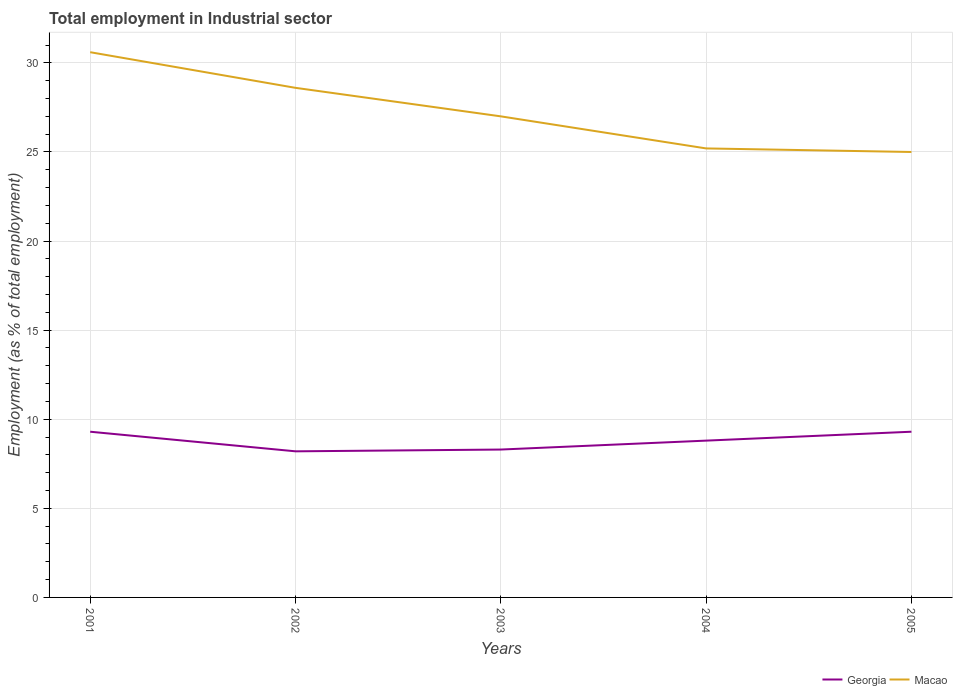How many different coloured lines are there?
Your answer should be compact. 2. What is the total employment in industrial sector in Macao in the graph?
Provide a succinct answer. 0.2. What is the difference between the highest and the second highest employment in industrial sector in Georgia?
Keep it short and to the point. 1.1. What is the difference between the highest and the lowest employment in industrial sector in Georgia?
Provide a succinct answer. 3. Is the employment in industrial sector in Macao strictly greater than the employment in industrial sector in Georgia over the years?
Provide a short and direct response. No. How many years are there in the graph?
Your answer should be very brief. 5. Does the graph contain any zero values?
Provide a succinct answer. No. What is the title of the graph?
Your answer should be compact. Total employment in Industrial sector. What is the label or title of the X-axis?
Offer a terse response. Years. What is the label or title of the Y-axis?
Offer a very short reply. Employment (as % of total employment). What is the Employment (as % of total employment) in Georgia in 2001?
Your answer should be compact. 9.3. What is the Employment (as % of total employment) of Macao in 2001?
Offer a very short reply. 30.6. What is the Employment (as % of total employment) in Georgia in 2002?
Offer a terse response. 8.2. What is the Employment (as % of total employment) in Macao in 2002?
Your response must be concise. 28.6. What is the Employment (as % of total employment) in Georgia in 2003?
Offer a terse response. 8.3. What is the Employment (as % of total employment) of Georgia in 2004?
Offer a terse response. 8.8. What is the Employment (as % of total employment) in Macao in 2004?
Ensure brevity in your answer.  25.2. What is the Employment (as % of total employment) in Georgia in 2005?
Provide a short and direct response. 9.3. Across all years, what is the maximum Employment (as % of total employment) in Georgia?
Give a very brief answer. 9.3. Across all years, what is the maximum Employment (as % of total employment) in Macao?
Give a very brief answer. 30.6. Across all years, what is the minimum Employment (as % of total employment) of Georgia?
Your response must be concise. 8.2. What is the total Employment (as % of total employment) in Georgia in the graph?
Make the answer very short. 43.9. What is the total Employment (as % of total employment) of Macao in the graph?
Your response must be concise. 136.4. What is the difference between the Employment (as % of total employment) of Macao in 2001 and that in 2003?
Provide a short and direct response. 3.6. What is the difference between the Employment (as % of total employment) of Georgia in 2001 and that in 2005?
Your response must be concise. 0. What is the difference between the Employment (as % of total employment) of Georgia in 2002 and that in 2003?
Provide a succinct answer. -0.1. What is the difference between the Employment (as % of total employment) of Macao in 2002 and that in 2003?
Offer a terse response. 1.6. What is the difference between the Employment (as % of total employment) in Georgia in 2002 and that in 2005?
Make the answer very short. -1.1. What is the difference between the Employment (as % of total employment) of Macao in 2002 and that in 2005?
Offer a terse response. 3.6. What is the difference between the Employment (as % of total employment) of Georgia in 2003 and that in 2004?
Your response must be concise. -0.5. What is the difference between the Employment (as % of total employment) of Macao in 2003 and that in 2004?
Keep it short and to the point. 1.8. What is the difference between the Employment (as % of total employment) in Georgia in 2003 and that in 2005?
Your response must be concise. -1. What is the difference between the Employment (as % of total employment) in Macao in 2003 and that in 2005?
Your answer should be compact. 2. What is the difference between the Employment (as % of total employment) of Georgia in 2004 and that in 2005?
Your answer should be very brief. -0.5. What is the difference between the Employment (as % of total employment) in Georgia in 2001 and the Employment (as % of total employment) in Macao in 2002?
Give a very brief answer. -19.3. What is the difference between the Employment (as % of total employment) of Georgia in 2001 and the Employment (as % of total employment) of Macao in 2003?
Ensure brevity in your answer.  -17.7. What is the difference between the Employment (as % of total employment) of Georgia in 2001 and the Employment (as % of total employment) of Macao in 2004?
Provide a succinct answer. -15.9. What is the difference between the Employment (as % of total employment) of Georgia in 2001 and the Employment (as % of total employment) of Macao in 2005?
Provide a short and direct response. -15.7. What is the difference between the Employment (as % of total employment) in Georgia in 2002 and the Employment (as % of total employment) in Macao in 2003?
Your answer should be compact. -18.8. What is the difference between the Employment (as % of total employment) in Georgia in 2002 and the Employment (as % of total employment) in Macao in 2004?
Make the answer very short. -17. What is the difference between the Employment (as % of total employment) of Georgia in 2002 and the Employment (as % of total employment) of Macao in 2005?
Your answer should be compact. -16.8. What is the difference between the Employment (as % of total employment) in Georgia in 2003 and the Employment (as % of total employment) in Macao in 2004?
Keep it short and to the point. -16.9. What is the difference between the Employment (as % of total employment) of Georgia in 2003 and the Employment (as % of total employment) of Macao in 2005?
Ensure brevity in your answer.  -16.7. What is the difference between the Employment (as % of total employment) in Georgia in 2004 and the Employment (as % of total employment) in Macao in 2005?
Provide a short and direct response. -16.2. What is the average Employment (as % of total employment) of Georgia per year?
Ensure brevity in your answer.  8.78. What is the average Employment (as % of total employment) in Macao per year?
Make the answer very short. 27.28. In the year 2001, what is the difference between the Employment (as % of total employment) in Georgia and Employment (as % of total employment) in Macao?
Make the answer very short. -21.3. In the year 2002, what is the difference between the Employment (as % of total employment) in Georgia and Employment (as % of total employment) in Macao?
Offer a terse response. -20.4. In the year 2003, what is the difference between the Employment (as % of total employment) of Georgia and Employment (as % of total employment) of Macao?
Make the answer very short. -18.7. In the year 2004, what is the difference between the Employment (as % of total employment) in Georgia and Employment (as % of total employment) in Macao?
Provide a short and direct response. -16.4. In the year 2005, what is the difference between the Employment (as % of total employment) of Georgia and Employment (as % of total employment) of Macao?
Your answer should be compact. -15.7. What is the ratio of the Employment (as % of total employment) in Georgia in 2001 to that in 2002?
Provide a succinct answer. 1.13. What is the ratio of the Employment (as % of total employment) of Macao in 2001 to that in 2002?
Your response must be concise. 1.07. What is the ratio of the Employment (as % of total employment) in Georgia in 2001 to that in 2003?
Provide a short and direct response. 1.12. What is the ratio of the Employment (as % of total employment) of Macao in 2001 to that in 2003?
Provide a succinct answer. 1.13. What is the ratio of the Employment (as % of total employment) in Georgia in 2001 to that in 2004?
Offer a very short reply. 1.06. What is the ratio of the Employment (as % of total employment) in Macao in 2001 to that in 2004?
Your answer should be very brief. 1.21. What is the ratio of the Employment (as % of total employment) in Georgia in 2001 to that in 2005?
Keep it short and to the point. 1. What is the ratio of the Employment (as % of total employment) in Macao in 2001 to that in 2005?
Offer a very short reply. 1.22. What is the ratio of the Employment (as % of total employment) in Macao in 2002 to that in 2003?
Your answer should be very brief. 1.06. What is the ratio of the Employment (as % of total employment) in Georgia in 2002 to that in 2004?
Offer a terse response. 0.93. What is the ratio of the Employment (as % of total employment) in Macao in 2002 to that in 2004?
Provide a succinct answer. 1.13. What is the ratio of the Employment (as % of total employment) of Georgia in 2002 to that in 2005?
Provide a short and direct response. 0.88. What is the ratio of the Employment (as % of total employment) in Macao in 2002 to that in 2005?
Give a very brief answer. 1.14. What is the ratio of the Employment (as % of total employment) of Georgia in 2003 to that in 2004?
Provide a short and direct response. 0.94. What is the ratio of the Employment (as % of total employment) in Macao in 2003 to that in 2004?
Offer a very short reply. 1.07. What is the ratio of the Employment (as % of total employment) in Georgia in 2003 to that in 2005?
Give a very brief answer. 0.89. What is the ratio of the Employment (as % of total employment) in Macao in 2003 to that in 2005?
Provide a short and direct response. 1.08. What is the ratio of the Employment (as % of total employment) of Georgia in 2004 to that in 2005?
Provide a succinct answer. 0.95. What is the difference between the highest and the second highest Employment (as % of total employment) in Georgia?
Offer a very short reply. 0. 